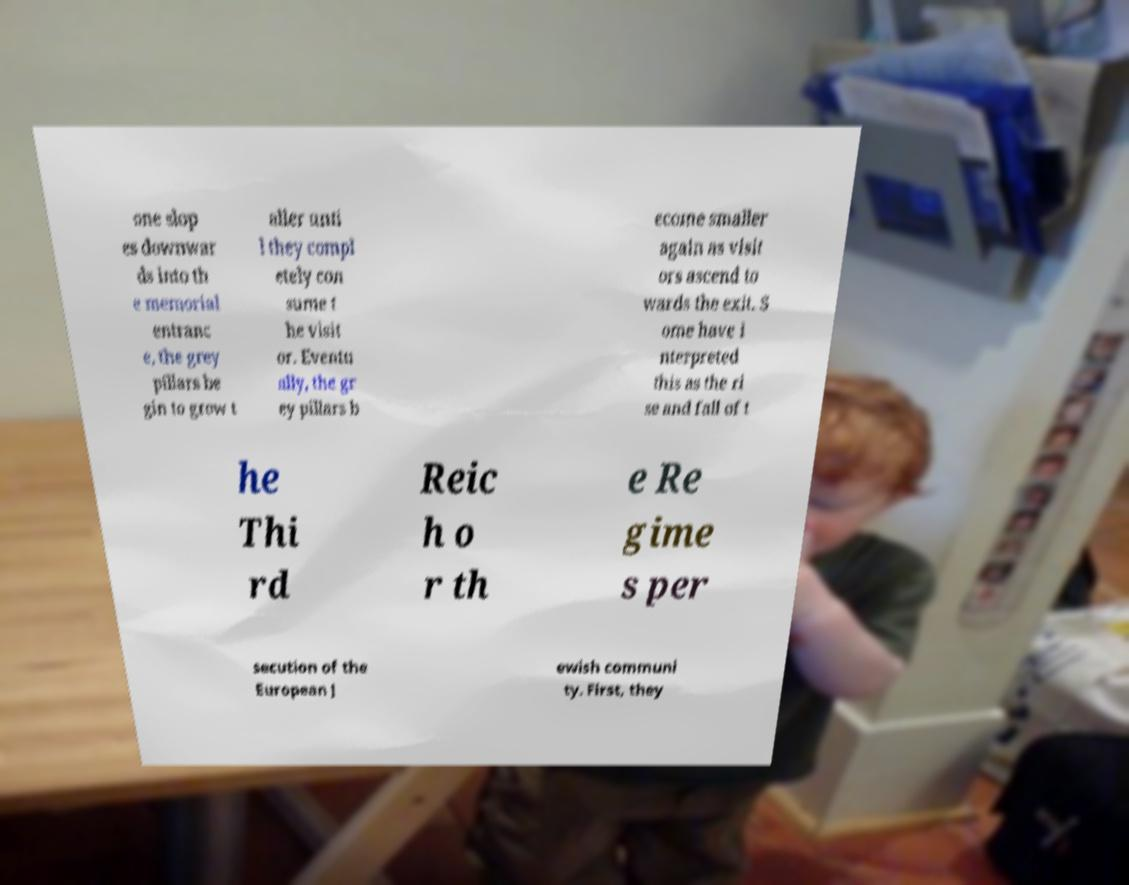Could you assist in decoding the text presented in this image and type it out clearly? one slop es downwar ds into th e memorial entranc e, the grey pillars be gin to grow t aller unti l they compl etely con sume t he visit or. Eventu ally, the gr ey pillars b ecome smaller again as visit ors ascend to wards the exit. S ome have i nterpreted this as the ri se and fall of t he Thi rd Reic h o r th e Re gime s per secution of the European J ewish communi ty. First, they 